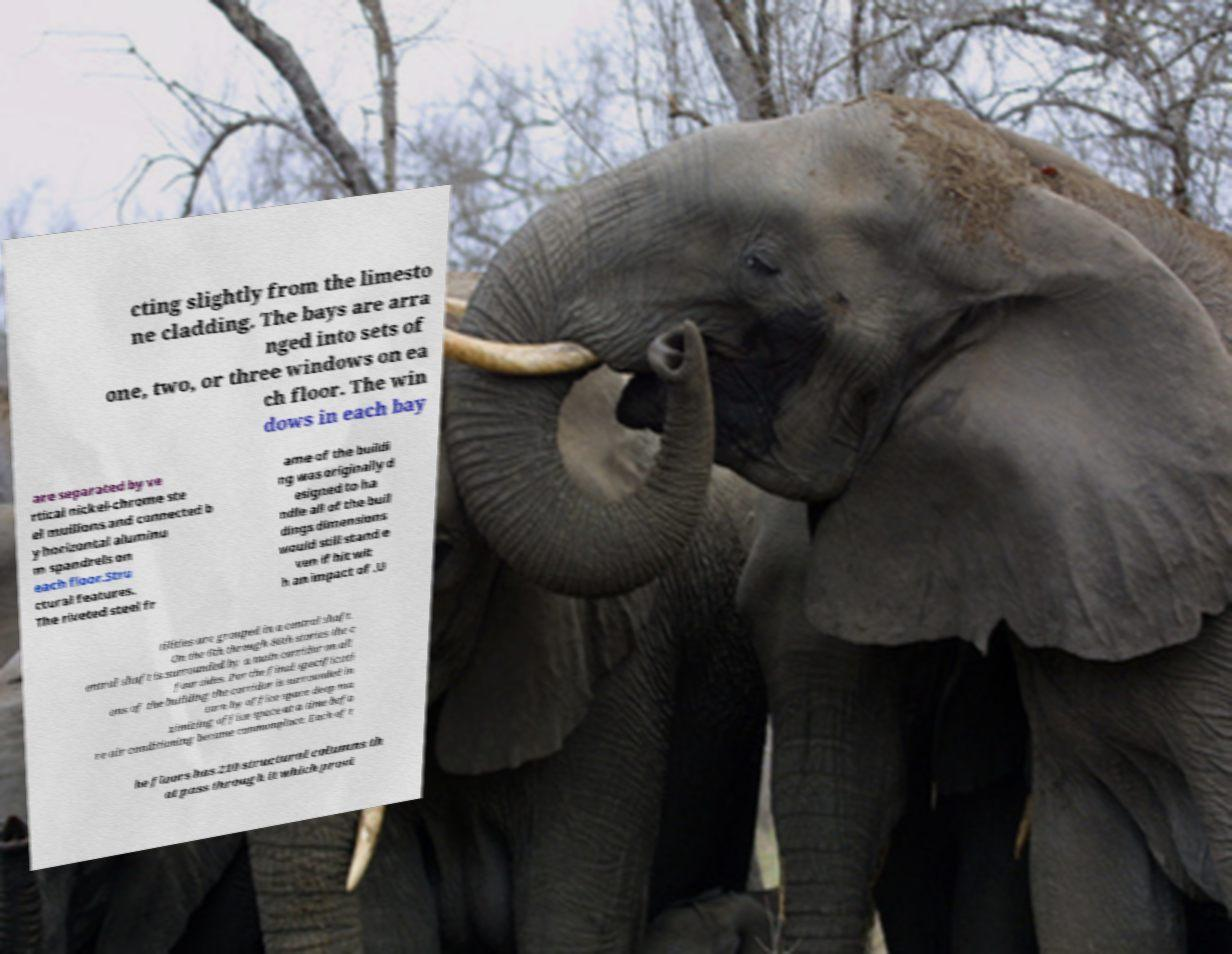What messages or text are displayed in this image? I need them in a readable, typed format. cting slightly from the limesto ne cladding. The bays are arra nged into sets of one, two, or three windows on ea ch floor. The win dows in each bay are separated by ve rtical nickel-chrome ste el mullions and connected b y horizontal aluminu m spandrels on each floor.Stru ctural features. The riveted steel fr ame of the buildi ng was originally d esigned to ha ndle all of the buil dings dimensions would still stand e ven if hit wit h an impact of .U tilities are grouped in a central shaft. On the 6th through 86th stories the c entral shaft is surrounded by a main corridor on all four sides. Per the final specificati ons of the building the corridor is surrounded in turn by office space deep ma ximizing office space at a time befo re air conditioning became commonplace. Each of t he floors has 210 structural columns th at pass through it which provi 